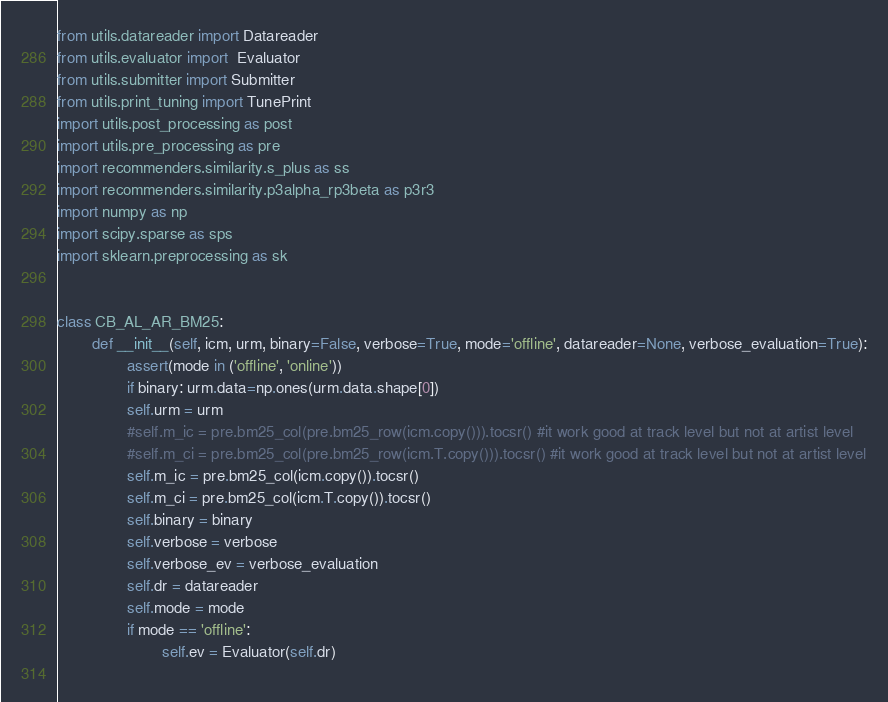<code> <loc_0><loc_0><loc_500><loc_500><_Python_>from utils.datareader import Datareader
from utils.evaluator import  Evaluator
from utils.submitter import Submitter
from utils.print_tuning import TunePrint
import utils.post_processing as post
import utils.pre_processing as pre
import recommenders.similarity.s_plus as ss
import recommenders.similarity.p3alpha_rp3beta as p3r3
import numpy as np
import scipy.sparse as sps
import sklearn.preprocessing as sk


class CB_AL_AR_BM25:
        def __init__(self, icm, urm, binary=False, verbose=True, mode='offline', datareader=None, verbose_evaluation=True):
                assert(mode in ('offline', 'online'))
                if binary: urm.data=np.ones(urm.data.shape[0])
                self.urm = urm
                #self.m_ic = pre.bm25_col(pre.bm25_row(icm.copy())).tocsr() #it work good at track level but not at artist level
                #self.m_ci = pre.bm25_col(pre.bm25_row(icm.T.copy())).tocsr() #it work good at track level but not at artist level
                self.m_ic = pre.bm25_col(icm.copy()).tocsr()
                self.m_ci = pre.bm25_col(icm.T.copy()).tocsr()
                self.binary = binary
                self.verbose = verbose
                self.verbose_ev = verbose_evaluation
                self.dr = datareader
                self.mode = mode
                if mode == 'offline':
                        self.ev = Evaluator(self.dr)
        </code> 